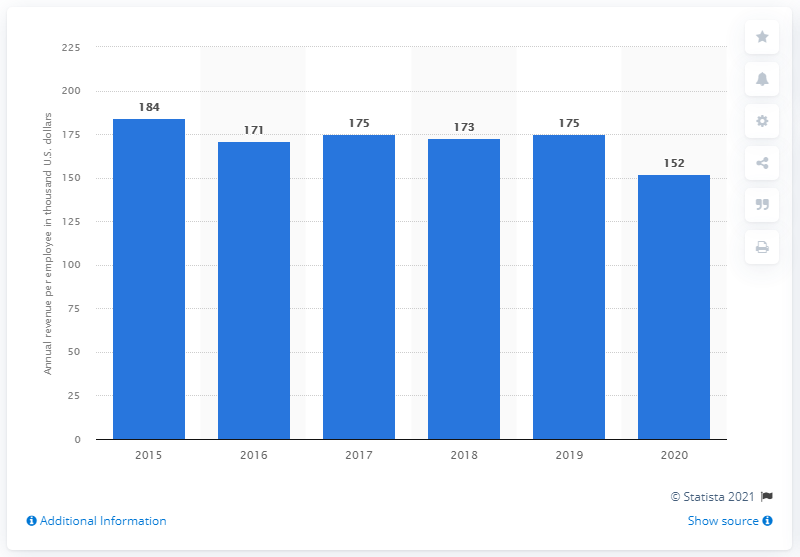Point out several critical features in this image. On average, each employee generated $175 in revenue over the course of 2 years. In 2018, the average revenue per employee was 173. 